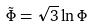Convert formula to latex. <formula><loc_0><loc_0><loc_500><loc_500>\tilde { \Phi } = \sqrt { 3 } \ln \Phi</formula> 